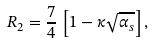<formula> <loc_0><loc_0><loc_500><loc_500>R _ { 2 } = \frac { 7 } { 4 } \, \left [ 1 - \kappa \sqrt { \alpha _ { s } } \right ] ,</formula> 